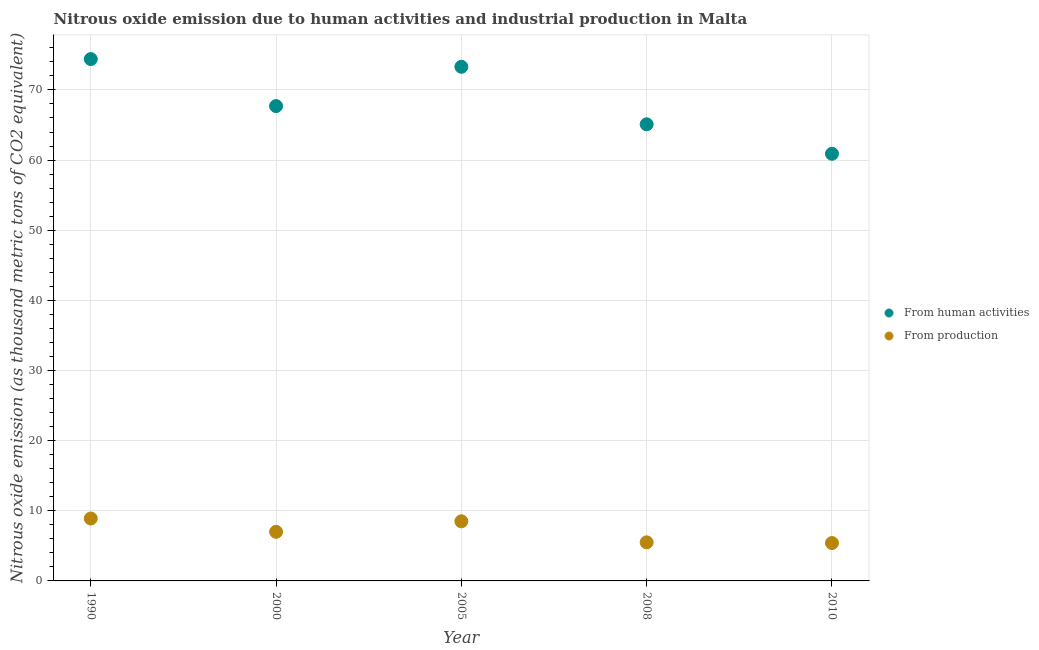What is the amount of emissions from human activities in 1990?
Keep it short and to the point. 74.4. Across all years, what is the maximum amount of emissions generated from industries?
Your response must be concise. 8.9. Across all years, what is the minimum amount of emissions generated from industries?
Make the answer very short. 5.4. What is the total amount of emissions generated from industries in the graph?
Ensure brevity in your answer.  35.3. What is the difference between the amount of emissions generated from industries in 1990 and that in 2010?
Provide a short and direct response. 3.5. What is the difference between the amount of emissions from human activities in 2005 and the amount of emissions generated from industries in 2008?
Your response must be concise. 67.8. What is the average amount of emissions generated from industries per year?
Your answer should be very brief. 7.06. In the year 2000, what is the difference between the amount of emissions from human activities and amount of emissions generated from industries?
Give a very brief answer. 60.7. In how many years, is the amount of emissions generated from industries greater than 38 thousand metric tons?
Keep it short and to the point. 0. What is the ratio of the amount of emissions generated from industries in 2000 to that in 2010?
Make the answer very short. 1.3. Is the amount of emissions generated from industries in 2005 less than that in 2010?
Provide a succinct answer. No. Is the difference between the amount of emissions generated from industries in 2000 and 2010 greater than the difference between the amount of emissions from human activities in 2000 and 2010?
Ensure brevity in your answer.  No. What is the difference between the highest and the second highest amount of emissions generated from industries?
Your answer should be very brief. 0.4. What is the difference between the highest and the lowest amount of emissions from human activities?
Your answer should be compact. 13.5. In how many years, is the amount of emissions from human activities greater than the average amount of emissions from human activities taken over all years?
Your answer should be compact. 2. Is the amount of emissions generated from industries strictly less than the amount of emissions from human activities over the years?
Your response must be concise. Yes. How many dotlines are there?
Provide a succinct answer. 2. What is the difference between two consecutive major ticks on the Y-axis?
Your answer should be very brief. 10. Does the graph contain any zero values?
Your response must be concise. No. Does the graph contain grids?
Keep it short and to the point. Yes. Where does the legend appear in the graph?
Offer a very short reply. Center right. How many legend labels are there?
Your answer should be compact. 2. What is the title of the graph?
Provide a short and direct response. Nitrous oxide emission due to human activities and industrial production in Malta. Does "International Tourists" appear as one of the legend labels in the graph?
Keep it short and to the point. No. What is the label or title of the Y-axis?
Make the answer very short. Nitrous oxide emission (as thousand metric tons of CO2 equivalent). What is the Nitrous oxide emission (as thousand metric tons of CO2 equivalent) of From human activities in 1990?
Offer a terse response. 74.4. What is the Nitrous oxide emission (as thousand metric tons of CO2 equivalent) of From production in 1990?
Ensure brevity in your answer.  8.9. What is the Nitrous oxide emission (as thousand metric tons of CO2 equivalent) in From human activities in 2000?
Your answer should be very brief. 67.7. What is the Nitrous oxide emission (as thousand metric tons of CO2 equivalent) in From production in 2000?
Your answer should be very brief. 7. What is the Nitrous oxide emission (as thousand metric tons of CO2 equivalent) in From human activities in 2005?
Offer a very short reply. 73.3. What is the Nitrous oxide emission (as thousand metric tons of CO2 equivalent) in From production in 2005?
Your answer should be very brief. 8.5. What is the Nitrous oxide emission (as thousand metric tons of CO2 equivalent) in From human activities in 2008?
Your answer should be very brief. 65.1. What is the Nitrous oxide emission (as thousand metric tons of CO2 equivalent) in From production in 2008?
Make the answer very short. 5.5. What is the Nitrous oxide emission (as thousand metric tons of CO2 equivalent) of From human activities in 2010?
Offer a very short reply. 60.9. Across all years, what is the maximum Nitrous oxide emission (as thousand metric tons of CO2 equivalent) of From human activities?
Make the answer very short. 74.4. Across all years, what is the minimum Nitrous oxide emission (as thousand metric tons of CO2 equivalent) in From human activities?
Give a very brief answer. 60.9. Across all years, what is the minimum Nitrous oxide emission (as thousand metric tons of CO2 equivalent) in From production?
Give a very brief answer. 5.4. What is the total Nitrous oxide emission (as thousand metric tons of CO2 equivalent) in From human activities in the graph?
Provide a succinct answer. 341.4. What is the total Nitrous oxide emission (as thousand metric tons of CO2 equivalent) of From production in the graph?
Provide a short and direct response. 35.3. What is the difference between the Nitrous oxide emission (as thousand metric tons of CO2 equivalent) in From human activities in 1990 and that in 2000?
Your answer should be very brief. 6.7. What is the difference between the Nitrous oxide emission (as thousand metric tons of CO2 equivalent) in From human activities in 1990 and that in 2005?
Provide a succinct answer. 1.1. What is the difference between the Nitrous oxide emission (as thousand metric tons of CO2 equivalent) of From production in 1990 and that in 2005?
Make the answer very short. 0.4. What is the difference between the Nitrous oxide emission (as thousand metric tons of CO2 equivalent) in From human activities in 1990 and that in 2008?
Give a very brief answer. 9.3. What is the difference between the Nitrous oxide emission (as thousand metric tons of CO2 equivalent) of From production in 1990 and that in 2010?
Keep it short and to the point. 3.5. What is the difference between the Nitrous oxide emission (as thousand metric tons of CO2 equivalent) of From production in 2000 and that in 2005?
Your response must be concise. -1.5. What is the difference between the Nitrous oxide emission (as thousand metric tons of CO2 equivalent) of From human activities in 2000 and that in 2008?
Give a very brief answer. 2.6. What is the difference between the Nitrous oxide emission (as thousand metric tons of CO2 equivalent) of From production in 2000 and that in 2008?
Give a very brief answer. 1.5. What is the difference between the Nitrous oxide emission (as thousand metric tons of CO2 equivalent) in From human activities in 2000 and that in 2010?
Give a very brief answer. 6.8. What is the difference between the Nitrous oxide emission (as thousand metric tons of CO2 equivalent) in From human activities in 1990 and the Nitrous oxide emission (as thousand metric tons of CO2 equivalent) in From production in 2000?
Your response must be concise. 67.4. What is the difference between the Nitrous oxide emission (as thousand metric tons of CO2 equivalent) of From human activities in 1990 and the Nitrous oxide emission (as thousand metric tons of CO2 equivalent) of From production in 2005?
Your answer should be very brief. 65.9. What is the difference between the Nitrous oxide emission (as thousand metric tons of CO2 equivalent) in From human activities in 1990 and the Nitrous oxide emission (as thousand metric tons of CO2 equivalent) in From production in 2008?
Your response must be concise. 68.9. What is the difference between the Nitrous oxide emission (as thousand metric tons of CO2 equivalent) of From human activities in 1990 and the Nitrous oxide emission (as thousand metric tons of CO2 equivalent) of From production in 2010?
Keep it short and to the point. 69. What is the difference between the Nitrous oxide emission (as thousand metric tons of CO2 equivalent) of From human activities in 2000 and the Nitrous oxide emission (as thousand metric tons of CO2 equivalent) of From production in 2005?
Offer a terse response. 59.2. What is the difference between the Nitrous oxide emission (as thousand metric tons of CO2 equivalent) in From human activities in 2000 and the Nitrous oxide emission (as thousand metric tons of CO2 equivalent) in From production in 2008?
Your response must be concise. 62.2. What is the difference between the Nitrous oxide emission (as thousand metric tons of CO2 equivalent) in From human activities in 2000 and the Nitrous oxide emission (as thousand metric tons of CO2 equivalent) in From production in 2010?
Provide a short and direct response. 62.3. What is the difference between the Nitrous oxide emission (as thousand metric tons of CO2 equivalent) of From human activities in 2005 and the Nitrous oxide emission (as thousand metric tons of CO2 equivalent) of From production in 2008?
Your answer should be compact. 67.8. What is the difference between the Nitrous oxide emission (as thousand metric tons of CO2 equivalent) in From human activities in 2005 and the Nitrous oxide emission (as thousand metric tons of CO2 equivalent) in From production in 2010?
Provide a short and direct response. 67.9. What is the difference between the Nitrous oxide emission (as thousand metric tons of CO2 equivalent) of From human activities in 2008 and the Nitrous oxide emission (as thousand metric tons of CO2 equivalent) of From production in 2010?
Offer a terse response. 59.7. What is the average Nitrous oxide emission (as thousand metric tons of CO2 equivalent) of From human activities per year?
Provide a succinct answer. 68.28. What is the average Nitrous oxide emission (as thousand metric tons of CO2 equivalent) of From production per year?
Your answer should be compact. 7.06. In the year 1990, what is the difference between the Nitrous oxide emission (as thousand metric tons of CO2 equivalent) in From human activities and Nitrous oxide emission (as thousand metric tons of CO2 equivalent) in From production?
Ensure brevity in your answer.  65.5. In the year 2000, what is the difference between the Nitrous oxide emission (as thousand metric tons of CO2 equivalent) of From human activities and Nitrous oxide emission (as thousand metric tons of CO2 equivalent) of From production?
Ensure brevity in your answer.  60.7. In the year 2005, what is the difference between the Nitrous oxide emission (as thousand metric tons of CO2 equivalent) of From human activities and Nitrous oxide emission (as thousand metric tons of CO2 equivalent) of From production?
Ensure brevity in your answer.  64.8. In the year 2008, what is the difference between the Nitrous oxide emission (as thousand metric tons of CO2 equivalent) in From human activities and Nitrous oxide emission (as thousand metric tons of CO2 equivalent) in From production?
Your response must be concise. 59.6. In the year 2010, what is the difference between the Nitrous oxide emission (as thousand metric tons of CO2 equivalent) in From human activities and Nitrous oxide emission (as thousand metric tons of CO2 equivalent) in From production?
Your answer should be compact. 55.5. What is the ratio of the Nitrous oxide emission (as thousand metric tons of CO2 equivalent) in From human activities in 1990 to that in 2000?
Your answer should be compact. 1.1. What is the ratio of the Nitrous oxide emission (as thousand metric tons of CO2 equivalent) of From production in 1990 to that in 2000?
Your response must be concise. 1.27. What is the ratio of the Nitrous oxide emission (as thousand metric tons of CO2 equivalent) of From production in 1990 to that in 2005?
Your response must be concise. 1.05. What is the ratio of the Nitrous oxide emission (as thousand metric tons of CO2 equivalent) of From human activities in 1990 to that in 2008?
Ensure brevity in your answer.  1.14. What is the ratio of the Nitrous oxide emission (as thousand metric tons of CO2 equivalent) in From production in 1990 to that in 2008?
Provide a succinct answer. 1.62. What is the ratio of the Nitrous oxide emission (as thousand metric tons of CO2 equivalent) in From human activities in 1990 to that in 2010?
Offer a very short reply. 1.22. What is the ratio of the Nitrous oxide emission (as thousand metric tons of CO2 equivalent) in From production in 1990 to that in 2010?
Offer a terse response. 1.65. What is the ratio of the Nitrous oxide emission (as thousand metric tons of CO2 equivalent) of From human activities in 2000 to that in 2005?
Give a very brief answer. 0.92. What is the ratio of the Nitrous oxide emission (as thousand metric tons of CO2 equivalent) of From production in 2000 to that in 2005?
Keep it short and to the point. 0.82. What is the ratio of the Nitrous oxide emission (as thousand metric tons of CO2 equivalent) in From human activities in 2000 to that in 2008?
Your answer should be compact. 1.04. What is the ratio of the Nitrous oxide emission (as thousand metric tons of CO2 equivalent) in From production in 2000 to that in 2008?
Provide a succinct answer. 1.27. What is the ratio of the Nitrous oxide emission (as thousand metric tons of CO2 equivalent) in From human activities in 2000 to that in 2010?
Provide a succinct answer. 1.11. What is the ratio of the Nitrous oxide emission (as thousand metric tons of CO2 equivalent) in From production in 2000 to that in 2010?
Give a very brief answer. 1.3. What is the ratio of the Nitrous oxide emission (as thousand metric tons of CO2 equivalent) of From human activities in 2005 to that in 2008?
Your answer should be very brief. 1.13. What is the ratio of the Nitrous oxide emission (as thousand metric tons of CO2 equivalent) in From production in 2005 to that in 2008?
Keep it short and to the point. 1.55. What is the ratio of the Nitrous oxide emission (as thousand metric tons of CO2 equivalent) of From human activities in 2005 to that in 2010?
Offer a very short reply. 1.2. What is the ratio of the Nitrous oxide emission (as thousand metric tons of CO2 equivalent) in From production in 2005 to that in 2010?
Provide a short and direct response. 1.57. What is the ratio of the Nitrous oxide emission (as thousand metric tons of CO2 equivalent) in From human activities in 2008 to that in 2010?
Your response must be concise. 1.07. What is the ratio of the Nitrous oxide emission (as thousand metric tons of CO2 equivalent) of From production in 2008 to that in 2010?
Keep it short and to the point. 1.02. What is the difference between the highest and the second highest Nitrous oxide emission (as thousand metric tons of CO2 equivalent) of From production?
Offer a very short reply. 0.4. 